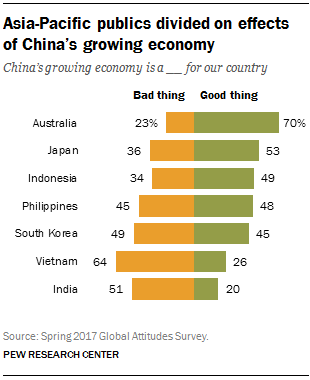Specify some key components in this picture. The lowest possible percentage of good things is 20%. The difference between the highest and lowest green bar is 50. 